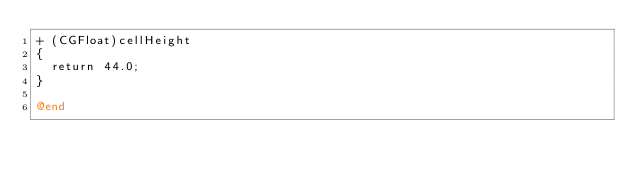Convert code to text. <code><loc_0><loc_0><loc_500><loc_500><_ObjectiveC_>+ (CGFloat)cellHeight
{
  return 44.0;
}

@end
</code> 